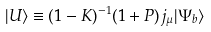Convert formula to latex. <formula><loc_0><loc_0><loc_500><loc_500>| U \rangle \equiv ( 1 - K ) ^ { - 1 } ( 1 + P ) j _ { \mu } | \Psi _ { b } \rangle</formula> 